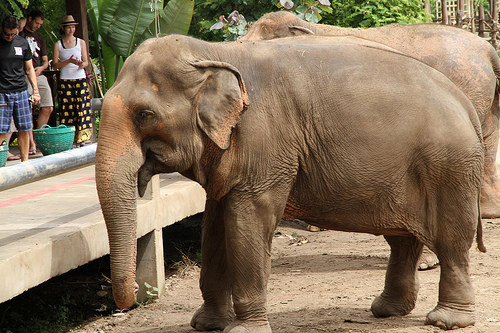On which side of the picture is the girl? The girl is on the left side of the picture. 